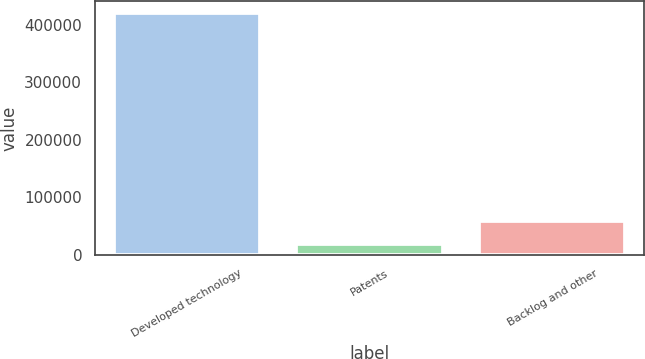<chart> <loc_0><loc_0><loc_500><loc_500><bar_chart><fcel>Developed technology<fcel>Patents<fcel>Backlog and other<nl><fcel>420887<fcel>18416<fcel>59127<nl></chart> 